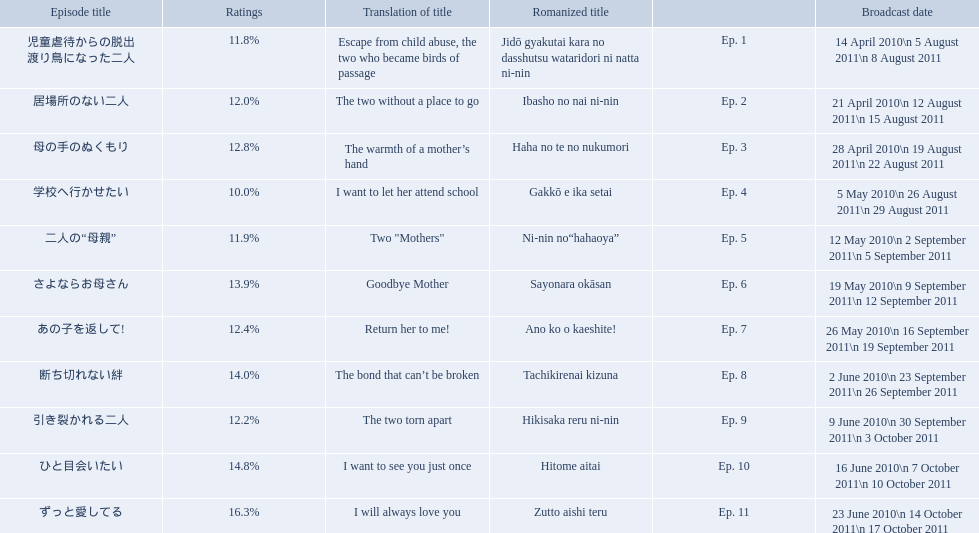What were the episode titles of mother? 児童虐待からの脱出 渡り鳥になった二人, 居場所のない二人, 母の手のぬくもり, 学校へ行かせたい, 二人の“母親”, さよならお母さん, あの子を返して!, 断ち切れない絆, 引き裂かれる二人, ひと目会いたい, ずっと愛してる. Which of these episodes had the highest ratings? ずっと愛してる. 